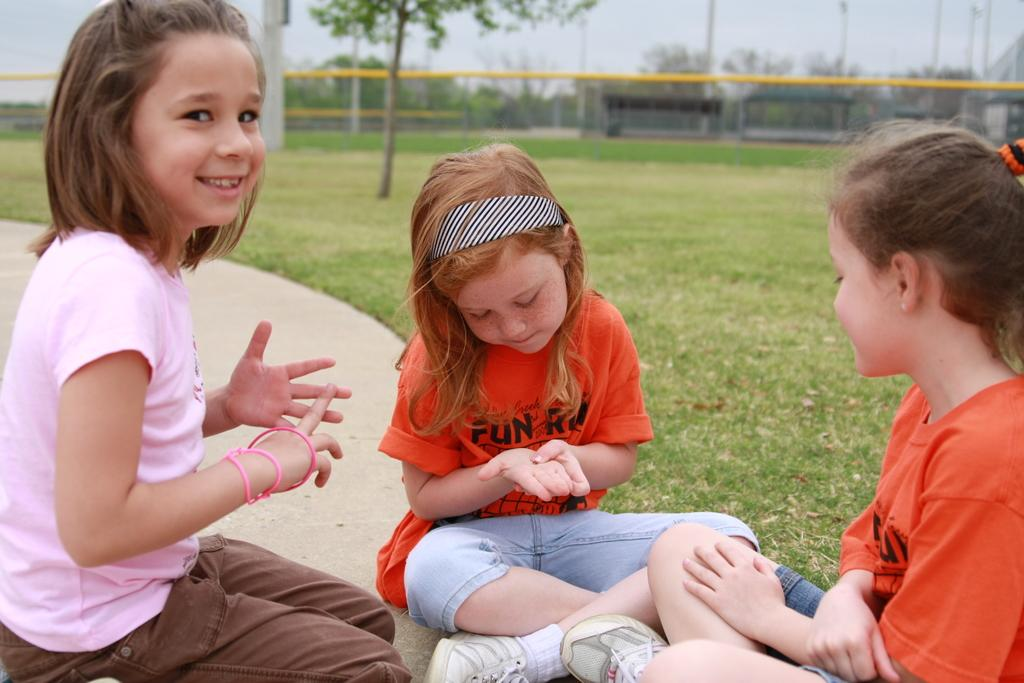How many girls are sitting in the image? There are three girls sitting in the image. What type of vegetation is visible in the image? There are trees in the image. What is on the ground in the image? There is grass on the ground in the image. What is visible at the top of the image? The sky is visible at the top of the image. How would you describe the background of the image? The background of the image is blurred. What type of fire can be seen in the image? There is no fire present in the image. What is the girls exchanging in the image? The image does not show the girls exchanging anything. 